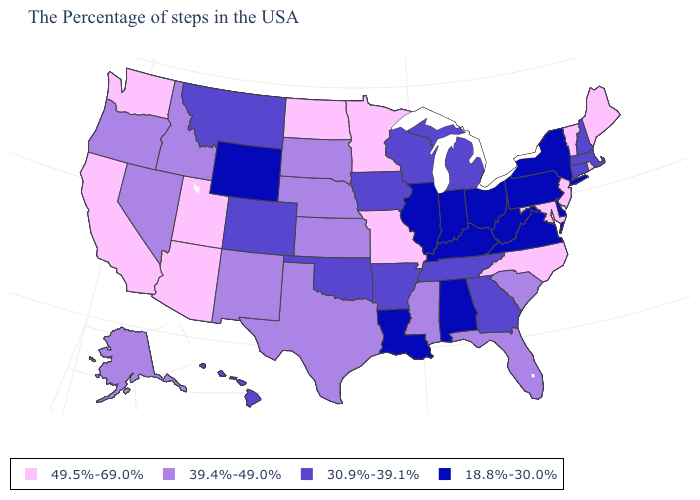What is the value of West Virginia?
Answer briefly. 18.8%-30.0%. What is the value of Oklahoma?
Write a very short answer. 30.9%-39.1%. What is the lowest value in the USA?
Answer briefly. 18.8%-30.0%. What is the value of Delaware?
Be succinct. 18.8%-30.0%. What is the highest value in the MidWest ?
Quick response, please. 49.5%-69.0%. Name the states that have a value in the range 39.4%-49.0%?
Keep it brief. South Carolina, Florida, Mississippi, Kansas, Nebraska, Texas, South Dakota, New Mexico, Idaho, Nevada, Oregon, Alaska. Which states have the highest value in the USA?
Be succinct. Maine, Rhode Island, Vermont, New Jersey, Maryland, North Carolina, Missouri, Minnesota, North Dakota, Utah, Arizona, California, Washington. Name the states that have a value in the range 30.9%-39.1%?
Write a very short answer. Massachusetts, New Hampshire, Connecticut, Georgia, Michigan, Tennessee, Wisconsin, Arkansas, Iowa, Oklahoma, Colorado, Montana, Hawaii. What is the value of New York?
Keep it brief. 18.8%-30.0%. What is the highest value in the Northeast ?
Give a very brief answer. 49.5%-69.0%. What is the value of Wisconsin?
Write a very short answer. 30.9%-39.1%. Name the states that have a value in the range 30.9%-39.1%?
Give a very brief answer. Massachusetts, New Hampshire, Connecticut, Georgia, Michigan, Tennessee, Wisconsin, Arkansas, Iowa, Oklahoma, Colorado, Montana, Hawaii. Which states have the lowest value in the USA?
Concise answer only. New York, Delaware, Pennsylvania, Virginia, West Virginia, Ohio, Kentucky, Indiana, Alabama, Illinois, Louisiana, Wyoming. Which states have the lowest value in the West?
Short answer required. Wyoming. Name the states that have a value in the range 49.5%-69.0%?
Short answer required. Maine, Rhode Island, Vermont, New Jersey, Maryland, North Carolina, Missouri, Minnesota, North Dakota, Utah, Arizona, California, Washington. 